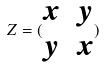Convert formula to latex. <formula><loc_0><loc_0><loc_500><loc_500>Z = ( \begin{matrix} x & y \\ y & x \end{matrix} )</formula> 